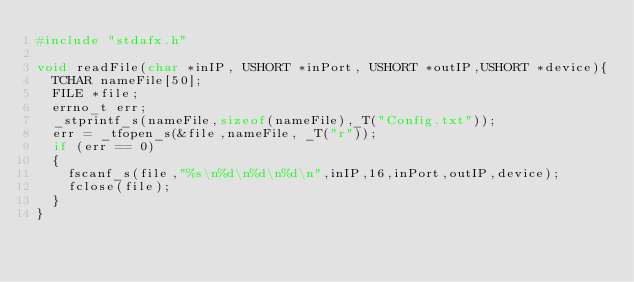<code> <loc_0><loc_0><loc_500><loc_500><_C++_>#include "stdafx.h"

void readFile(char *inIP, USHORT *inPort, USHORT *outIP,USHORT *device){
	TCHAR nameFile[50];
	FILE *file;
	errno_t err;
	_stprintf_s(nameFile,sizeof(nameFile),_T("Config.txt"));
	err = _tfopen_s(&file,nameFile, _T("r"));
	if (err == 0)
	{
		fscanf_s(file,"%s\n%d\n%d\n%d\n",inIP,16,inPort,outIP,device);
		fclose(file);
	}
}

</code> 